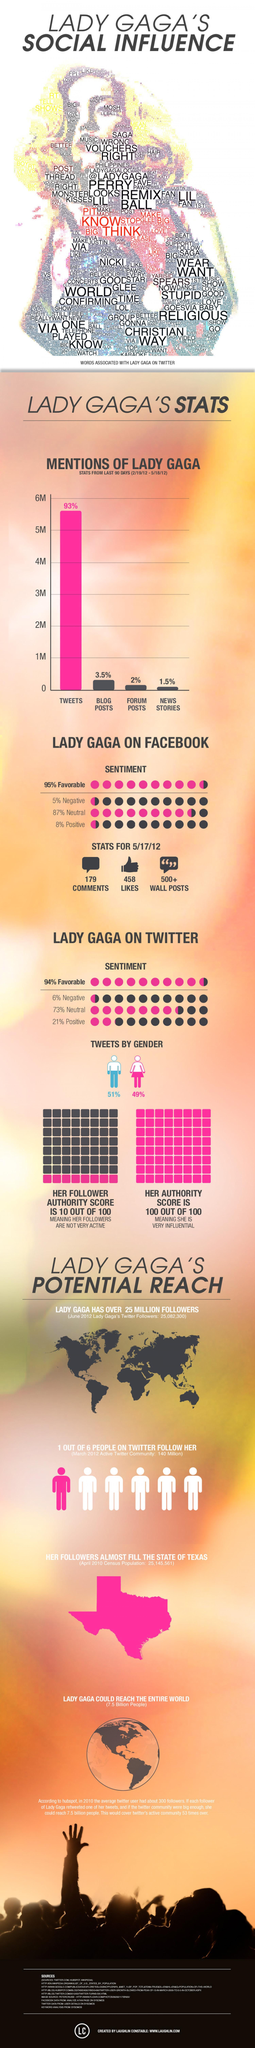what is the total percentage of responses in Twitter on Lady Gaga that are not neutral?
Answer the question with a short phrase. 15 which platform has more talk on Lady Gaga - twitter or news stories? twitter what is the total percentage of responses in Twitter on Lady Gaga that are not negative? 95% 